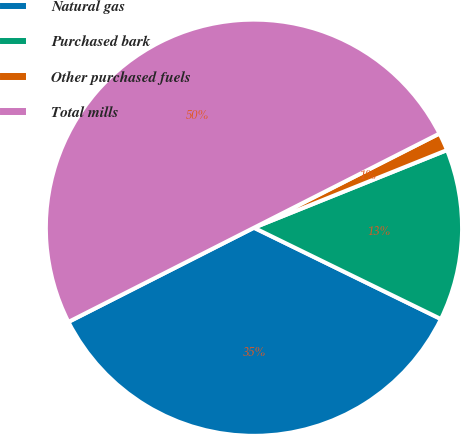Convert chart to OTSL. <chart><loc_0><loc_0><loc_500><loc_500><pie_chart><fcel>Natural gas<fcel>Purchased bark<fcel>Other purchased fuels<fcel>Total mills<nl><fcel>35.29%<fcel>13.32%<fcel>1.39%<fcel>50.0%<nl></chart> 